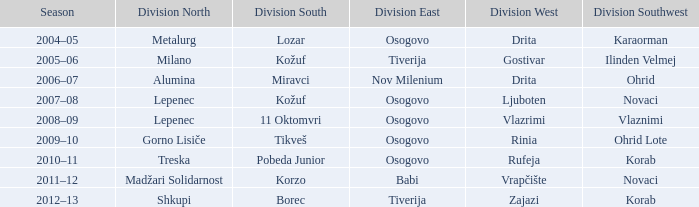Who emerged victorious in division southwest when division north's champion was lepenec and 11 oktomvri triumphed in division south? Vlaznimi. 